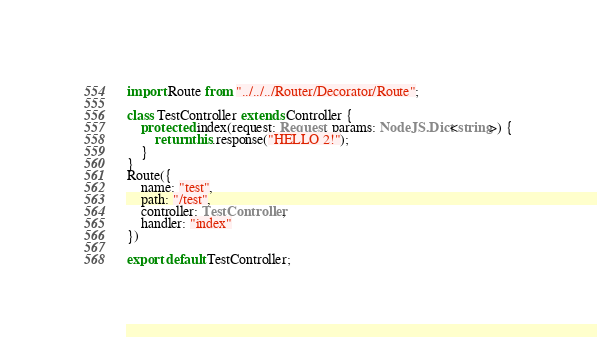Convert code to text. <code><loc_0><loc_0><loc_500><loc_500><_TypeScript_>import Route from "../../../Router/Decorator/Route";

class TestController extends Controller {
	protected index(request: Request, params: NodeJS.Dict<string>) {
		return this.response("HELLO 2!");
	}
}
Route({
	name: "test",
	path: "/test",
	controller: TestController,
	handler: "index"
})

export default TestController;
</code> 